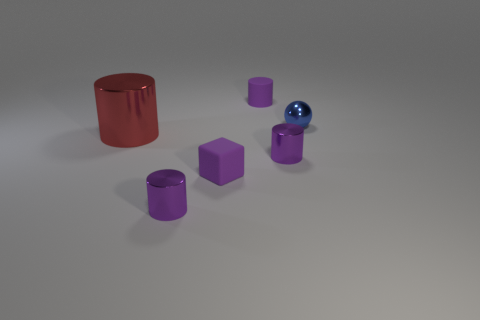How many purple cylinders must be subtracted to get 1 purple cylinders? 2 Add 3 purple shiny objects. How many objects exist? 9 Subtract all small purple cylinders. How many cylinders are left? 1 Subtract all cylinders. How many objects are left? 2 Subtract all red cylinders. How many cylinders are left? 3 Add 6 tiny purple rubber blocks. How many tiny purple rubber blocks are left? 7 Add 2 purple shiny cylinders. How many purple shiny cylinders exist? 4 Subtract 0 brown balls. How many objects are left? 6 Subtract 2 cylinders. How many cylinders are left? 2 Subtract all yellow spheres. Subtract all blue blocks. How many spheres are left? 1 